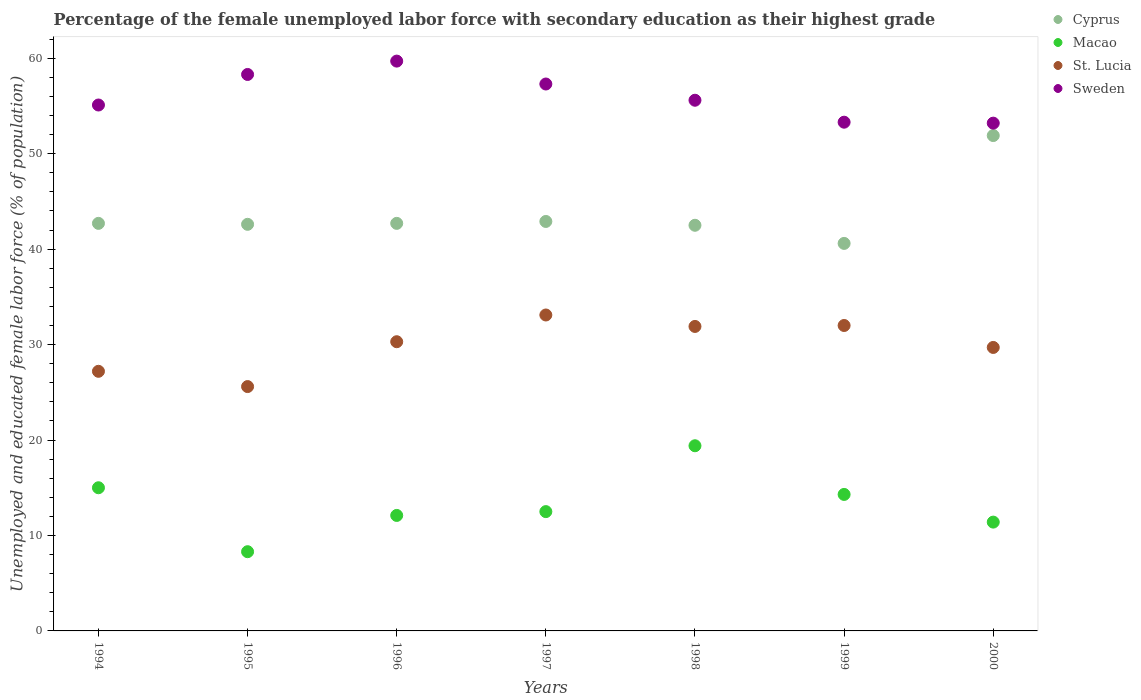What is the percentage of the unemployed female labor force with secondary education in Cyprus in 1999?
Your response must be concise. 40.6. Across all years, what is the maximum percentage of the unemployed female labor force with secondary education in Macao?
Provide a short and direct response. 19.4. Across all years, what is the minimum percentage of the unemployed female labor force with secondary education in Sweden?
Ensure brevity in your answer.  53.2. In which year was the percentage of the unemployed female labor force with secondary education in Cyprus maximum?
Keep it short and to the point. 2000. What is the total percentage of the unemployed female labor force with secondary education in Macao in the graph?
Your response must be concise. 93. What is the difference between the percentage of the unemployed female labor force with secondary education in Cyprus in 1994 and that in 1996?
Offer a very short reply. 0. What is the difference between the percentage of the unemployed female labor force with secondary education in Macao in 1998 and the percentage of the unemployed female labor force with secondary education in St. Lucia in 1995?
Your answer should be compact. -6.2. What is the average percentage of the unemployed female labor force with secondary education in St. Lucia per year?
Keep it short and to the point. 29.97. In the year 1999, what is the difference between the percentage of the unemployed female labor force with secondary education in St. Lucia and percentage of the unemployed female labor force with secondary education in Sweden?
Give a very brief answer. -21.3. What is the ratio of the percentage of the unemployed female labor force with secondary education in Macao in 1995 to that in 2000?
Offer a very short reply. 0.73. What is the difference between the highest and the second highest percentage of the unemployed female labor force with secondary education in Sweden?
Offer a terse response. 1.4. What is the difference between the highest and the lowest percentage of the unemployed female labor force with secondary education in St. Lucia?
Offer a terse response. 7.5. In how many years, is the percentage of the unemployed female labor force with secondary education in Macao greater than the average percentage of the unemployed female labor force with secondary education in Macao taken over all years?
Give a very brief answer. 3. Is the percentage of the unemployed female labor force with secondary education in Cyprus strictly less than the percentage of the unemployed female labor force with secondary education in Macao over the years?
Ensure brevity in your answer.  No. How many dotlines are there?
Make the answer very short. 4. Are the values on the major ticks of Y-axis written in scientific E-notation?
Offer a terse response. No. Does the graph contain any zero values?
Keep it short and to the point. No. Does the graph contain grids?
Offer a terse response. No. What is the title of the graph?
Your answer should be compact. Percentage of the female unemployed labor force with secondary education as their highest grade. Does "Cuba" appear as one of the legend labels in the graph?
Make the answer very short. No. What is the label or title of the X-axis?
Your answer should be very brief. Years. What is the label or title of the Y-axis?
Your answer should be very brief. Unemployed and educated female labor force (% of population). What is the Unemployed and educated female labor force (% of population) of Cyprus in 1994?
Offer a terse response. 42.7. What is the Unemployed and educated female labor force (% of population) of St. Lucia in 1994?
Provide a short and direct response. 27.2. What is the Unemployed and educated female labor force (% of population) of Sweden in 1994?
Give a very brief answer. 55.1. What is the Unemployed and educated female labor force (% of population) of Cyprus in 1995?
Give a very brief answer. 42.6. What is the Unemployed and educated female labor force (% of population) of Macao in 1995?
Give a very brief answer. 8.3. What is the Unemployed and educated female labor force (% of population) in St. Lucia in 1995?
Keep it short and to the point. 25.6. What is the Unemployed and educated female labor force (% of population) of Sweden in 1995?
Provide a succinct answer. 58.3. What is the Unemployed and educated female labor force (% of population) of Cyprus in 1996?
Offer a very short reply. 42.7. What is the Unemployed and educated female labor force (% of population) of Macao in 1996?
Provide a succinct answer. 12.1. What is the Unemployed and educated female labor force (% of population) in St. Lucia in 1996?
Ensure brevity in your answer.  30.3. What is the Unemployed and educated female labor force (% of population) of Sweden in 1996?
Your answer should be very brief. 59.7. What is the Unemployed and educated female labor force (% of population) of Cyprus in 1997?
Your answer should be compact. 42.9. What is the Unemployed and educated female labor force (% of population) in Macao in 1997?
Make the answer very short. 12.5. What is the Unemployed and educated female labor force (% of population) in St. Lucia in 1997?
Provide a succinct answer. 33.1. What is the Unemployed and educated female labor force (% of population) in Sweden in 1997?
Provide a succinct answer. 57.3. What is the Unemployed and educated female labor force (% of population) in Cyprus in 1998?
Offer a terse response. 42.5. What is the Unemployed and educated female labor force (% of population) of Macao in 1998?
Ensure brevity in your answer.  19.4. What is the Unemployed and educated female labor force (% of population) in St. Lucia in 1998?
Give a very brief answer. 31.9. What is the Unemployed and educated female labor force (% of population) in Sweden in 1998?
Give a very brief answer. 55.6. What is the Unemployed and educated female labor force (% of population) of Cyprus in 1999?
Your answer should be very brief. 40.6. What is the Unemployed and educated female labor force (% of population) of Macao in 1999?
Your response must be concise. 14.3. What is the Unemployed and educated female labor force (% of population) in Sweden in 1999?
Offer a very short reply. 53.3. What is the Unemployed and educated female labor force (% of population) of Cyprus in 2000?
Provide a succinct answer. 51.9. What is the Unemployed and educated female labor force (% of population) of Macao in 2000?
Ensure brevity in your answer.  11.4. What is the Unemployed and educated female labor force (% of population) in St. Lucia in 2000?
Offer a terse response. 29.7. What is the Unemployed and educated female labor force (% of population) in Sweden in 2000?
Make the answer very short. 53.2. Across all years, what is the maximum Unemployed and educated female labor force (% of population) in Cyprus?
Your answer should be compact. 51.9. Across all years, what is the maximum Unemployed and educated female labor force (% of population) in Macao?
Ensure brevity in your answer.  19.4. Across all years, what is the maximum Unemployed and educated female labor force (% of population) in St. Lucia?
Your answer should be very brief. 33.1. Across all years, what is the maximum Unemployed and educated female labor force (% of population) of Sweden?
Provide a short and direct response. 59.7. Across all years, what is the minimum Unemployed and educated female labor force (% of population) in Cyprus?
Your response must be concise. 40.6. Across all years, what is the minimum Unemployed and educated female labor force (% of population) of Macao?
Your answer should be very brief. 8.3. Across all years, what is the minimum Unemployed and educated female labor force (% of population) in St. Lucia?
Your response must be concise. 25.6. Across all years, what is the minimum Unemployed and educated female labor force (% of population) of Sweden?
Make the answer very short. 53.2. What is the total Unemployed and educated female labor force (% of population) in Cyprus in the graph?
Make the answer very short. 305.9. What is the total Unemployed and educated female labor force (% of population) in Macao in the graph?
Give a very brief answer. 93. What is the total Unemployed and educated female labor force (% of population) in St. Lucia in the graph?
Offer a very short reply. 209.8. What is the total Unemployed and educated female labor force (% of population) in Sweden in the graph?
Provide a short and direct response. 392.5. What is the difference between the Unemployed and educated female labor force (% of population) of Cyprus in 1994 and that in 1995?
Keep it short and to the point. 0.1. What is the difference between the Unemployed and educated female labor force (% of population) of St. Lucia in 1994 and that in 1995?
Your response must be concise. 1.6. What is the difference between the Unemployed and educated female labor force (% of population) in Macao in 1994 and that in 1996?
Give a very brief answer. 2.9. What is the difference between the Unemployed and educated female labor force (% of population) in St. Lucia in 1994 and that in 1996?
Keep it short and to the point. -3.1. What is the difference between the Unemployed and educated female labor force (% of population) of Sweden in 1994 and that in 1996?
Offer a very short reply. -4.6. What is the difference between the Unemployed and educated female labor force (% of population) in St. Lucia in 1994 and that in 1997?
Provide a succinct answer. -5.9. What is the difference between the Unemployed and educated female labor force (% of population) of Cyprus in 1994 and that in 1999?
Your response must be concise. 2.1. What is the difference between the Unemployed and educated female labor force (% of population) in Sweden in 1994 and that in 1999?
Provide a short and direct response. 1.8. What is the difference between the Unemployed and educated female labor force (% of population) in Cyprus in 1994 and that in 2000?
Offer a very short reply. -9.2. What is the difference between the Unemployed and educated female labor force (% of population) in Cyprus in 1995 and that in 1996?
Offer a very short reply. -0.1. What is the difference between the Unemployed and educated female labor force (% of population) in St. Lucia in 1995 and that in 1996?
Give a very brief answer. -4.7. What is the difference between the Unemployed and educated female labor force (% of population) in Macao in 1995 and that in 1997?
Provide a succinct answer. -4.2. What is the difference between the Unemployed and educated female labor force (% of population) of Cyprus in 1995 and that in 1998?
Ensure brevity in your answer.  0.1. What is the difference between the Unemployed and educated female labor force (% of population) of Macao in 1995 and that in 1998?
Your answer should be compact. -11.1. What is the difference between the Unemployed and educated female labor force (% of population) of St. Lucia in 1995 and that in 1998?
Ensure brevity in your answer.  -6.3. What is the difference between the Unemployed and educated female labor force (% of population) of Cyprus in 1995 and that in 1999?
Offer a terse response. 2. What is the difference between the Unemployed and educated female labor force (% of population) in Macao in 1995 and that in 1999?
Your answer should be very brief. -6. What is the difference between the Unemployed and educated female labor force (% of population) of St. Lucia in 1995 and that in 1999?
Your response must be concise. -6.4. What is the difference between the Unemployed and educated female labor force (% of population) in Cyprus in 1995 and that in 2000?
Your answer should be compact. -9.3. What is the difference between the Unemployed and educated female labor force (% of population) in Sweden in 1995 and that in 2000?
Offer a very short reply. 5.1. What is the difference between the Unemployed and educated female labor force (% of population) in Macao in 1996 and that in 1997?
Provide a short and direct response. -0.4. What is the difference between the Unemployed and educated female labor force (% of population) in St. Lucia in 1996 and that in 1998?
Offer a very short reply. -1.6. What is the difference between the Unemployed and educated female labor force (% of population) in Cyprus in 1996 and that in 1999?
Make the answer very short. 2.1. What is the difference between the Unemployed and educated female labor force (% of population) of Macao in 1996 and that in 1999?
Your response must be concise. -2.2. What is the difference between the Unemployed and educated female labor force (% of population) of St. Lucia in 1996 and that in 1999?
Ensure brevity in your answer.  -1.7. What is the difference between the Unemployed and educated female labor force (% of population) in St. Lucia in 1996 and that in 2000?
Provide a succinct answer. 0.6. What is the difference between the Unemployed and educated female labor force (% of population) in Macao in 1997 and that in 1998?
Keep it short and to the point. -6.9. What is the difference between the Unemployed and educated female labor force (% of population) in Macao in 1997 and that in 1999?
Your answer should be very brief. -1.8. What is the difference between the Unemployed and educated female labor force (% of population) in St. Lucia in 1997 and that in 1999?
Your response must be concise. 1.1. What is the difference between the Unemployed and educated female labor force (% of population) of St. Lucia in 1997 and that in 2000?
Provide a short and direct response. 3.4. What is the difference between the Unemployed and educated female labor force (% of population) in Macao in 1998 and that in 1999?
Offer a terse response. 5.1. What is the difference between the Unemployed and educated female labor force (% of population) in St. Lucia in 1998 and that in 1999?
Offer a terse response. -0.1. What is the difference between the Unemployed and educated female labor force (% of population) of Sweden in 1998 and that in 1999?
Keep it short and to the point. 2.3. What is the difference between the Unemployed and educated female labor force (% of population) of Macao in 1998 and that in 2000?
Your response must be concise. 8. What is the difference between the Unemployed and educated female labor force (% of population) in St. Lucia in 1998 and that in 2000?
Offer a terse response. 2.2. What is the difference between the Unemployed and educated female labor force (% of population) of Macao in 1999 and that in 2000?
Ensure brevity in your answer.  2.9. What is the difference between the Unemployed and educated female labor force (% of population) of St. Lucia in 1999 and that in 2000?
Offer a terse response. 2.3. What is the difference between the Unemployed and educated female labor force (% of population) in Sweden in 1999 and that in 2000?
Keep it short and to the point. 0.1. What is the difference between the Unemployed and educated female labor force (% of population) of Cyprus in 1994 and the Unemployed and educated female labor force (% of population) of Macao in 1995?
Your answer should be compact. 34.4. What is the difference between the Unemployed and educated female labor force (% of population) in Cyprus in 1994 and the Unemployed and educated female labor force (% of population) in St. Lucia in 1995?
Keep it short and to the point. 17.1. What is the difference between the Unemployed and educated female labor force (% of population) of Cyprus in 1994 and the Unemployed and educated female labor force (% of population) of Sweden in 1995?
Your answer should be compact. -15.6. What is the difference between the Unemployed and educated female labor force (% of population) of Macao in 1994 and the Unemployed and educated female labor force (% of population) of Sweden in 1995?
Give a very brief answer. -43.3. What is the difference between the Unemployed and educated female labor force (% of population) of St. Lucia in 1994 and the Unemployed and educated female labor force (% of population) of Sweden in 1995?
Offer a very short reply. -31.1. What is the difference between the Unemployed and educated female labor force (% of population) in Cyprus in 1994 and the Unemployed and educated female labor force (% of population) in Macao in 1996?
Ensure brevity in your answer.  30.6. What is the difference between the Unemployed and educated female labor force (% of population) of Cyprus in 1994 and the Unemployed and educated female labor force (% of population) of St. Lucia in 1996?
Ensure brevity in your answer.  12.4. What is the difference between the Unemployed and educated female labor force (% of population) in Macao in 1994 and the Unemployed and educated female labor force (% of population) in St. Lucia in 1996?
Your answer should be very brief. -15.3. What is the difference between the Unemployed and educated female labor force (% of population) of Macao in 1994 and the Unemployed and educated female labor force (% of population) of Sweden in 1996?
Your answer should be compact. -44.7. What is the difference between the Unemployed and educated female labor force (% of population) in St. Lucia in 1994 and the Unemployed and educated female labor force (% of population) in Sweden in 1996?
Give a very brief answer. -32.5. What is the difference between the Unemployed and educated female labor force (% of population) of Cyprus in 1994 and the Unemployed and educated female labor force (% of population) of Macao in 1997?
Provide a short and direct response. 30.2. What is the difference between the Unemployed and educated female labor force (% of population) of Cyprus in 1994 and the Unemployed and educated female labor force (% of population) of Sweden in 1997?
Offer a very short reply. -14.6. What is the difference between the Unemployed and educated female labor force (% of population) of Macao in 1994 and the Unemployed and educated female labor force (% of population) of St. Lucia in 1997?
Provide a succinct answer. -18.1. What is the difference between the Unemployed and educated female labor force (% of population) of Macao in 1994 and the Unemployed and educated female labor force (% of population) of Sweden in 1997?
Provide a succinct answer. -42.3. What is the difference between the Unemployed and educated female labor force (% of population) in St. Lucia in 1994 and the Unemployed and educated female labor force (% of population) in Sweden in 1997?
Give a very brief answer. -30.1. What is the difference between the Unemployed and educated female labor force (% of population) in Cyprus in 1994 and the Unemployed and educated female labor force (% of population) in Macao in 1998?
Make the answer very short. 23.3. What is the difference between the Unemployed and educated female labor force (% of population) in Cyprus in 1994 and the Unemployed and educated female labor force (% of population) in St. Lucia in 1998?
Offer a very short reply. 10.8. What is the difference between the Unemployed and educated female labor force (% of population) in Macao in 1994 and the Unemployed and educated female labor force (% of population) in St. Lucia in 1998?
Provide a short and direct response. -16.9. What is the difference between the Unemployed and educated female labor force (% of population) of Macao in 1994 and the Unemployed and educated female labor force (% of population) of Sweden in 1998?
Your answer should be compact. -40.6. What is the difference between the Unemployed and educated female labor force (% of population) of St. Lucia in 1994 and the Unemployed and educated female labor force (% of population) of Sweden in 1998?
Keep it short and to the point. -28.4. What is the difference between the Unemployed and educated female labor force (% of population) in Cyprus in 1994 and the Unemployed and educated female labor force (% of population) in Macao in 1999?
Make the answer very short. 28.4. What is the difference between the Unemployed and educated female labor force (% of population) of Macao in 1994 and the Unemployed and educated female labor force (% of population) of Sweden in 1999?
Keep it short and to the point. -38.3. What is the difference between the Unemployed and educated female labor force (% of population) in St. Lucia in 1994 and the Unemployed and educated female labor force (% of population) in Sweden in 1999?
Offer a very short reply. -26.1. What is the difference between the Unemployed and educated female labor force (% of population) of Cyprus in 1994 and the Unemployed and educated female labor force (% of population) of Macao in 2000?
Give a very brief answer. 31.3. What is the difference between the Unemployed and educated female labor force (% of population) of Macao in 1994 and the Unemployed and educated female labor force (% of population) of St. Lucia in 2000?
Give a very brief answer. -14.7. What is the difference between the Unemployed and educated female labor force (% of population) of Macao in 1994 and the Unemployed and educated female labor force (% of population) of Sweden in 2000?
Provide a short and direct response. -38.2. What is the difference between the Unemployed and educated female labor force (% of population) in St. Lucia in 1994 and the Unemployed and educated female labor force (% of population) in Sweden in 2000?
Your response must be concise. -26. What is the difference between the Unemployed and educated female labor force (% of population) of Cyprus in 1995 and the Unemployed and educated female labor force (% of population) of Macao in 1996?
Offer a very short reply. 30.5. What is the difference between the Unemployed and educated female labor force (% of population) in Cyprus in 1995 and the Unemployed and educated female labor force (% of population) in St. Lucia in 1996?
Offer a very short reply. 12.3. What is the difference between the Unemployed and educated female labor force (% of population) in Cyprus in 1995 and the Unemployed and educated female labor force (% of population) in Sweden in 1996?
Give a very brief answer. -17.1. What is the difference between the Unemployed and educated female labor force (% of population) in Macao in 1995 and the Unemployed and educated female labor force (% of population) in St. Lucia in 1996?
Provide a succinct answer. -22. What is the difference between the Unemployed and educated female labor force (% of population) of Macao in 1995 and the Unemployed and educated female labor force (% of population) of Sweden in 1996?
Your answer should be very brief. -51.4. What is the difference between the Unemployed and educated female labor force (% of population) in St. Lucia in 1995 and the Unemployed and educated female labor force (% of population) in Sweden in 1996?
Provide a succinct answer. -34.1. What is the difference between the Unemployed and educated female labor force (% of population) of Cyprus in 1995 and the Unemployed and educated female labor force (% of population) of Macao in 1997?
Keep it short and to the point. 30.1. What is the difference between the Unemployed and educated female labor force (% of population) in Cyprus in 1995 and the Unemployed and educated female labor force (% of population) in St. Lucia in 1997?
Your answer should be compact. 9.5. What is the difference between the Unemployed and educated female labor force (% of population) of Cyprus in 1995 and the Unemployed and educated female labor force (% of population) of Sweden in 1997?
Offer a very short reply. -14.7. What is the difference between the Unemployed and educated female labor force (% of population) in Macao in 1995 and the Unemployed and educated female labor force (% of population) in St. Lucia in 1997?
Offer a terse response. -24.8. What is the difference between the Unemployed and educated female labor force (% of population) of Macao in 1995 and the Unemployed and educated female labor force (% of population) of Sweden in 1997?
Make the answer very short. -49. What is the difference between the Unemployed and educated female labor force (% of population) in St. Lucia in 1995 and the Unemployed and educated female labor force (% of population) in Sweden in 1997?
Your answer should be compact. -31.7. What is the difference between the Unemployed and educated female labor force (% of population) in Cyprus in 1995 and the Unemployed and educated female labor force (% of population) in Macao in 1998?
Provide a succinct answer. 23.2. What is the difference between the Unemployed and educated female labor force (% of population) of Cyprus in 1995 and the Unemployed and educated female labor force (% of population) of St. Lucia in 1998?
Give a very brief answer. 10.7. What is the difference between the Unemployed and educated female labor force (% of population) of Macao in 1995 and the Unemployed and educated female labor force (% of population) of St. Lucia in 1998?
Make the answer very short. -23.6. What is the difference between the Unemployed and educated female labor force (% of population) of Macao in 1995 and the Unemployed and educated female labor force (% of population) of Sweden in 1998?
Make the answer very short. -47.3. What is the difference between the Unemployed and educated female labor force (% of population) of St. Lucia in 1995 and the Unemployed and educated female labor force (% of population) of Sweden in 1998?
Offer a very short reply. -30. What is the difference between the Unemployed and educated female labor force (% of population) in Cyprus in 1995 and the Unemployed and educated female labor force (% of population) in Macao in 1999?
Offer a terse response. 28.3. What is the difference between the Unemployed and educated female labor force (% of population) in Cyprus in 1995 and the Unemployed and educated female labor force (% of population) in St. Lucia in 1999?
Your answer should be very brief. 10.6. What is the difference between the Unemployed and educated female labor force (% of population) of Cyprus in 1995 and the Unemployed and educated female labor force (% of population) of Sweden in 1999?
Your response must be concise. -10.7. What is the difference between the Unemployed and educated female labor force (% of population) in Macao in 1995 and the Unemployed and educated female labor force (% of population) in St. Lucia in 1999?
Your answer should be compact. -23.7. What is the difference between the Unemployed and educated female labor force (% of population) in Macao in 1995 and the Unemployed and educated female labor force (% of population) in Sweden in 1999?
Offer a terse response. -45. What is the difference between the Unemployed and educated female labor force (% of population) of St. Lucia in 1995 and the Unemployed and educated female labor force (% of population) of Sweden in 1999?
Provide a short and direct response. -27.7. What is the difference between the Unemployed and educated female labor force (% of population) of Cyprus in 1995 and the Unemployed and educated female labor force (% of population) of Macao in 2000?
Make the answer very short. 31.2. What is the difference between the Unemployed and educated female labor force (% of population) of Cyprus in 1995 and the Unemployed and educated female labor force (% of population) of St. Lucia in 2000?
Your answer should be very brief. 12.9. What is the difference between the Unemployed and educated female labor force (% of population) of Macao in 1995 and the Unemployed and educated female labor force (% of population) of St. Lucia in 2000?
Give a very brief answer. -21.4. What is the difference between the Unemployed and educated female labor force (% of population) of Macao in 1995 and the Unemployed and educated female labor force (% of population) of Sweden in 2000?
Give a very brief answer. -44.9. What is the difference between the Unemployed and educated female labor force (% of population) in St. Lucia in 1995 and the Unemployed and educated female labor force (% of population) in Sweden in 2000?
Provide a short and direct response. -27.6. What is the difference between the Unemployed and educated female labor force (% of population) of Cyprus in 1996 and the Unemployed and educated female labor force (% of population) of Macao in 1997?
Ensure brevity in your answer.  30.2. What is the difference between the Unemployed and educated female labor force (% of population) of Cyprus in 1996 and the Unemployed and educated female labor force (% of population) of St. Lucia in 1997?
Provide a succinct answer. 9.6. What is the difference between the Unemployed and educated female labor force (% of population) in Cyprus in 1996 and the Unemployed and educated female labor force (% of population) in Sweden in 1997?
Provide a short and direct response. -14.6. What is the difference between the Unemployed and educated female labor force (% of population) in Macao in 1996 and the Unemployed and educated female labor force (% of population) in Sweden in 1997?
Make the answer very short. -45.2. What is the difference between the Unemployed and educated female labor force (% of population) of St. Lucia in 1996 and the Unemployed and educated female labor force (% of population) of Sweden in 1997?
Offer a very short reply. -27. What is the difference between the Unemployed and educated female labor force (% of population) in Cyprus in 1996 and the Unemployed and educated female labor force (% of population) in Macao in 1998?
Offer a very short reply. 23.3. What is the difference between the Unemployed and educated female labor force (% of population) in Cyprus in 1996 and the Unemployed and educated female labor force (% of population) in Sweden in 1998?
Offer a terse response. -12.9. What is the difference between the Unemployed and educated female labor force (% of population) of Macao in 1996 and the Unemployed and educated female labor force (% of population) of St. Lucia in 1998?
Offer a terse response. -19.8. What is the difference between the Unemployed and educated female labor force (% of population) of Macao in 1996 and the Unemployed and educated female labor force (% of population) of Sweden in 1998?
Offer a terse response. -43.5. What is the difference between the Unemployed and educated female labor force (% of population) in St. Lucia in 1996 and the Unemployed and educated female labor force (% of population) in Sweden in 1998?
Provide a short and direct response. -25.3. What is the difference between the Unemployed and educated female labor force (% of population) of Cyprus in 1996 and the Unemployed and educated female labor force (% of population) of Macao in 1999?
Offer a terse response. 28.4. What is the difference between the Unemployed and educated female labor force (% of population) of Cyprus in 1996 and the Unemployed and educated female labor force (% of population) of St. Lucia in 1999?
Make the answer very short. 10.7. What is the difference between the Unemployed and educated female labor force (% of population) of Macao in 1996 and the Unemployed and educated female labor force (% of population) of St. Lucia in 1999?
Offer a very short reply. -19.9. What is the difference between the Unemployed and educated female labor force (% of population) of Macao in 1996 and the Unemployed and educated female labor force (% of population) of Sweden in 1999?
Your answer should be very brief. -41.2. What is the difference between the Unemployed and educated female labor force (% of population) in St. Lucia in 1996 and the Unemployed and educated female labor force (% of population) in Sweden in 1999?
Provide a short and direct response. -23. What is the difference between the Unemployed and educated female labor force (% of population) in Cyprus in 1996 and the Unemployed and educated female labor force (% of population) in Macao in 2000?
Your answer should be compact. 31.3. What is the difference between the Unemployed and educated female labor force (% of population) in Macao in 1996 and the Unemployed and educated female labor force (% of population) in St. Lucia in 2000?
Give a very brief answer. -17.6. What is the difference between the Unemployed and educated female labor force (% of population) of Macao in 1996 and the Unemployed and educated female labor force (% of population) of Sweden in 2000?
Make the answer very short. -41.1. What is the difference between the Unemployed and educated female labor force (% of population) of St. Lucia in 1996 and the Unemployed and educated female labor force (% of population) of Sweden in 2000?
Ensure brevity in your answer.  -22.9. What is the difference between the Unemployed and educated female labor force (% of population) of Macao in 1997 and the Unemployed and educated female labor force (% of population) of St. Lucia in 1998?
Offer a very short reply. -19.4. What is the difference between the Unemployed and educated female labor force (% of population) in Macao in 1997 and the Unemployed and educated female labor force (% of population) in Sweden in 1998?
Your answer should be compact. -43.1. What is the difference between the Unemployed and educated female labor force (% of population) of St. Lucia in 1997 and the Unemployed and educated female labor force (% of population) of Sweden in 1998?
Offer a very short reply. -22.5. What is the difference between the Unemployed and educated female labor force (% of population) in Cyprus in 1997 and the Unemployed and educated female labor force (% of population) in Macao in 1999?
Make the answer very short. 28.6. What is the difference between the Unemployed and educated female labor force (% of population) in Cyprus in 1997 and the Unemployed and educated female labor force (% of population) in Sweden in 1999?
Offer a very short reply. -10.4. What is the difference between the Unemployed and educated female labor force (% of population) of Macao in 1997 and the Unemployed and educated female labor force (% of population) of St. Lucia in 1999?
Offer a terse response. -19.5. What is the difference between the Unemployed and educated female labor force (% of population) of Macao in 1997 and the Unemployed and educated female labor force (% of population) of Sweden in 1999?
Offer a terse response. -40.8. What is the difference between the Unemployed and educated female labor force (% of population) of St. Lucia in 1997 and the Unemployed and educated female labor force (% of population) of Sweden in 1999?
Keep it short and to the point. -20.2. What is the difference between the Unemployed and educated female labor force (% of population) in Cyprus in 1997 and the Unemployed and educated female labor force (% of population) in Macao in 2000?
Your answer should be compact. 31.5. What is the difference between the Unemployed and educated female labor force (% of population) of Macao in 1997 and the Unemployed and educated female labor force (% of population) of St. Lucia in 2000?
Make the answer very short. -17.2. What is the difference between the Unemployed and educated female labor force (% of population) in Macao in 1997 and the Unemployed and educated female labor force (% of population) in Sweden in 2000?
Provide a succinct answer. -40.7. What is the difference between the Unemployed and educated female labor force (% of population) of St. Lucia in 1997 and the Unemployed and educated female labor force (% of population) of Sweden in 2000?
Offer a terse response. -20.1. What is the difference between the Unemployed and educated female labor force (% of population) of Cyprus in 1998 and the Unemployed and educated female labor force (% of population) of Macao in 1999?
Keep it short and to the point. 28.2. What is the difference between the Unemployed and educated female labor force (% of population) in Cyprus in 1998 and the Unemployed and educated female labor force (% of population) in Sweden in 1999?
Offer a terse response. -10.8. What is the difference between the Unemployed and educated female labor force (% of population) in Macao in 1998 and the Unemployed and educated female labor force (% of population) in St. Lucia in 1999?
Keep it short and to the point. -12.6. What is the difference between the Unemployed and educated female labor force (% of population) in Macao in 1998 and the Unemployed and educated female labor force (% of population) in Sweden in 1999?
Offer a very short reply. -33.9. What is the difference between the Unemployed and educated female labor force (% of population) of St. Lucia in 1998 and the Unemployed and educated female labor force (% of population) of Sweden in 1999?
Your response must be concise. -21.4. What is the difference between the Unemployed and educated female labor force (% of population) in Cyprus in 1998 and the Unemployed and educated female labor force (% of population) in Macao in 2000?
Offer a terse response. 31.1. What is the difference between the Unemployed and educated female labor force (% of population) of Macao in 1998 and the Unemployed and educated female labor force (% of population) of Sweden in 2000?
Keep it short and to the point. -33.8. What is the difference between the Unemployed and educated female labor force (% of population) in St. Lucia in 1998 and the Unemployed and educated female labor force (% of population) in Sweden in 2000?
Your response must be concise. -21.3. What is the difference between the Unemployed and educated female labor force (% of population) of Cyprus in 1999 and the Unemployed and educated female labor force (% of population) of Macao in 2000?
Keep it short and to the point. 29.2. What is the difference between the Unemployed and educated female labor force (% of population) of Cyprus in 1999 and the Unemployed and educated female labor force (% of population) of Sweden in 2000?
Make the answer very short. -12.6. What is the difference between the Unemployed and educated female labor force (% of population) of Macao in 1999 and the Unemployed and educated female labor force (% of population) of St. Lucia in 2000?
Make the answer very short. -15.4. What is the difference between the Unemployed and educated female labor force (% of population) of Macao in 1999 and the Unemployed and educated female labor force (% of population) of Sweden in 2000?
Your answer should be compact. -38.9. What is the difference between the Unemployed and educated female labor force (% of population) in St. Lucia in 1999 and the Unemployed and educated female labor force (% of population) in Sweden in 2000?
Offer a very short reply. -21.2. What is the average Unemployed and educated female labor force (% of population) of Cyprus per year?
Offer a very short reply. 43.7. What is the average Unemployed and educated female labor force (% of population) in Macao per year?
Your answer should be very brief. 13.29. What is the average Unemployed and educated female labor force (% of population) in St. Lucia per year?
Your response must be concise. 29.97. What is the average Unemployed and educated female labor force (% of population) of Sweden per year?
Your answer should be very brief. 56.07. In the year 1994, what is the difference between the Unemployed and educated female labor force (% of population) of Cyprus and Unemployed and educated female labor force (% of population) of Macao?
Provide a succinct answer. 27.7. In the year 1994, what is the difference between the Unemployed and educated female labor force (% of population) of Cyprus and Unemployed and educated female labor force (% of population) of Sweden?
Ensure brevity in your answer.  -12.4. In the year 1994, what is the difference between the Unemployed and educated female labor force (% of population) in Macao and Unemployed and educated female labor force (% of population) in St. Lucia?
Your response must be concise. -12.2. In the year 1994, what is the difference between the Unemployed and educated female labor force (% of population) in Macao and Unemployed and educated female labor force (% of population) in Sweden?
Provide a succinct answer. -40.1. In the year 1994, what is the difference between the Unemployed and educated female labor force (% of population) of St. Lucia and Unemployed and educated female labor force (% of population) of Sweden?
Ensure brevity in your answer.  -27.9. In the year 1995, what is the difference between the Unemployed and educated female labor force (% of population) in Cyprus and Unemployed and educated female labor force (% of population) in Macao?
Ensure brevity in your answer.  34.3. In the year 1995, what is the difference between the Unemployed and educated female labor force (% of population) of Cyprus and Unemployed and educated female labor force (% of population) of St. Lucia?
Keep it short and to the point. 17. In the year 1995, what is the difference between the Unemployed and educated female labor force (% of population) in Cyprus and Unemployed and educated female labor force (% of population) in Sweden?
Keep it short and to the point. -15.7. In the year 1995, what is the difference between the Unemployed and educated female labor force (% of population) of Macao and Unemployed and educated female labor force (% of population) of St. Lucia?
Ensure brevity in your answer.  -17.3. In the year 1995, what is the difference between the Unemployed and educated female labor force (% of population) of Macao and Unemployed and educated female labor force (% of population) of Sweden?
Ensure brevity in your answer.  -50. In the year 1995, what is the difference between the Unemployed and educated female labor force (% of population) in St. Lucia and Unemployed and educated female labor force (% of population) in Sweden?
Keep it short and to the point. -32.7. In the year 1996, what is the difference between the Unemployed and educated female labor force (% of population) in Cyprus and Unemployed and educated female labor force (% of population) in Macao?
Offer a very short reply. 30.6. In the year 1996, what is the difference between the Unemployed and educated female labor force (% of population) in Macao and Unemployed and educated female labor force (% of population) in St. Lucia?
Provide a short and direct response. -18.2. In the year 1996, what is the difference between the Unemployed and educated female labor force (% of population) in Macao and Unemployed and educated female labor force (% of population) in Sweden?
Ensure brevity in your answer.  -47.6. In the year 1996, what is the difference between the Unemployed and educated female labor force (% of population) of St. Lucia and Unemployed and educated female labor force (% of population) of Sweden?
Provide a succinct answer. -29.4. In the year 1997, what is the difference between the Unemployed and educated female labor force (% of population) of Cyprus and Unemployed and educated female labor force (% of population) of Macao?
Your answer should be compact. 30.4. In the year 1997, what is the difference between the Unemployed and educated female labor force (% of population) of Cyprus and Unemployed and educated female labor force (% of population) of St. Lucia?
Your answer should be very brief. 9.8. In the year 1997, what is the difference between the Unemployed and educated female labor force (% of population) in Cyprus and Unemployed and educated female labor force (% of population) in Sweden?
Make the answer very short. -14.4. In the year 1997, what is the difference between the Unemployed and educated female labor force (% of population) in Macao and Unemployed and educated female labor force (% of population) in St. Lucia?
Your answer should be compact. -20.6. In the year 1997, what is the difference between the Unemployed and educated female labor force (% of population) in Macao and Unemployed and educated female labor force (% of population) in Sweden?
Make the answer very short. -44.8. In the year 1997, what is the difference between the Unemployed and educated female labor force (% of population) of St. Lucia and Unemployed and educated female labor force (% of population) of Sweden?
Offer a very short reply. -24.2. In the year 1998, what is the difference between the Unemployed and educated female labor force (% of population) of Cyprus and Unemployed and educated female labor force (% of population) of Macao?
Offer a very short reply. 23.1. In the year 1998, what is the difference between the Unemployed and educated female labor force (% of population) in Cyprus and Unemployed and educated female labor force (% of population) in Sweden?
Your answer should be compact. -13.1. In the year 1998, what is the difference between the Unemployed and educated female labor force (% of population) of Macao and Unemployed and educated female labor force (% of population) of Sweden?
Your answer should be very brief. -36.2. In the year 1998, what is the difference between the Unemployed and educated female labor force (% of population) in St. Lucia and Unemployed and educated female labor force (% of population) in Sweden?
Give a very brief answer. -23.7. In the year 1999, what is the difference between the Unemployed and educated female labor force (% of population) of Cyprus and Unemployed and educated female labor force (% of population) of Macao?
Offer a terse response. 26.3. In the year 1999, what is the difference between the Unemployed and educated female labor force (% of population) of Cyprus and Unemployed and educated female labor force (% of population) of St. Lucia?
Offer a terse response. 8.6. In the year 1999, what is the difference between the Unemployed and educated female labor force (% of population) in Cyprus and Unemployed and educated female labor force (% of population) in Sweden?
Your response must be concise. -12.7. In the year 1999, what is the difference between the Unemployed and educated female labor force (% of population) of Macao and Unemployed and educated female labor force (% of population) of St. Lucia?
Give a very brief answer. -17.7. In the year 1999, what is the difference between the Unemployed and educated female labor force (% of population) of Macao and Unemployed and educated female labor force (% of population) of Sweden?
Your response must be concise. -39. In the year 1999, what is the difference between the Unemployed and educated female labor force (% of population) of St. Lucia and Unemployed and educated female labor force (% of population) of Sweden?
Provide a succinct answer. -21.3. In the year 2000, what is the difference between the Unemployed and educated female labor force (% of population) in Cyprus and Unemployed and educated female labor force (% of population) in Macao?
Keep it short and to the point. 40.5. In the year 2000, what is the difference between the Unemployed and educated female labor force (% of population) in Cyprus and Unemployed and educated female labor force (% of population) in St. Lucia?
Give a very brief answer. 22.2. In the year 2000, what is the difference between the Unemployed and educated female labor force (% of population) in Macao and Unemployed and educated female labor force (% of population) in St. Lucia?
Your answer should be compact. -18.3. In the year 2000, what is the difference between the Unemployed and educated female labor force (% of population) of Macao and Unemployed and educated female labor force (% of population) of Sweden?
Your response must be concise. -41.8. In the year 2000, what is the difference between the Unemployed and educated female labor force (% of population) of St. Lucia and Unemployed and educated female labor force (% of population) of Sweden?
Ensure brevity in your answer.  -23.5. What is the ratio of the Unemployed and educated female labor force (% of population) of Macao in 1994 to that in 1995?
Offer a very short reply. 1.81. What is the ratio of the Unemployed and educated female labor force (% of population) in St. Lucia in 1994 to that in 1995?
Provide a succinct answer. 1.06. What is the ratio of the Unemployed and educated female labor force (% of population) of Sweden in 1994 to that in 1995?
Offer a very short reply. 0.95. What is the ratio of the Unemployed and educated female labor force (% of population) of Macao in 1994 to that in 1996?
Provide a succinct answer. 1.24. What is the ratio of the Unemployed and educated female labor force (% of population) of St. Lucia in 1994 to that in 1996?
Your answer should be compact. 0.9. What is the ratio of the Unemployed and educated female labor force (% of population) of Sweden in 1994 to that in 1996?
Your answer should be compact. 0.92. What is the ratio of the Unemployed and educated female labor force (% of population) of Cyprus in 1994 to that in 1997?
Provide a succinct answer. 1. What is the ratio of the Unemployed and educated female labor force (% of population) in St. Lucia in 1994 to that in 1997?
Offer a very short reply. 0.82. What is the ratio of the Unemployed and educated female labor force (% of population) of Sweden in 1994 to that in 1997?
Your response must be concise. 0.96. What is the ratio of the Unemployed and educated female labor force (% of population) of Macao in 1994 to that in 1998?
Make the answer very short. 0.77. What is the ratio of the Unemployed and educated female labor force (% of population) in St. Lucia in 1994 to that in 1998?
Offer a terse response. 0.85. What is the ratio of the Unemployed and educated female labor force (% of population) of Cyprus in 1994 to that in 1999?
Your answer should be very brief. 1.05. What is the ratio of the Unemployed and educated female labor force (% of population) in Macao in 1994 to that in 1999?
Offer a terse response. 1.05. What is the ratio of the Unemployed and educated female labor force (% of population) in Sweden in 1994 to that in 1999?
Your response must be concise. 1.03. What is the ratio of the Unemployed and educated female labor force (% of population) of Cyprus in 1994 to that in 2000?
Your answer should be very brief. 0.82. What is the ratio of the Unemployed and educated female labor force (% of population) in Macao in 1994 to that in 2000?
Provide a succinct answer. 1.32. What is the ratio of the Unemployed and educated female labor force (% of population) in St. Lucia in 1994 to that in 2000?
Offer a very short reply. 0.92. What is the ratio of the Unemployed and educated female labor force (% of population) in Sweden in 1994 to that in 2000?
Your answer should be compact. 1.04. What is the ratio of the Unemployed and educated female labor force (% of population) of Macao in 1995 to that in 1996?
Your answer should be very brief. 0.69. What is the ratio of the Unemployed and educated female labor force (% of population) of St. Lucia in 1995 to that in 1996?
Your answer should be compact. 0.84. What is the ratio of the Unemployed and educated female labor force (% of population) in Sweden in 1995 to that in 1996?
Offer a terse response. 0.98. What is the ratio of the Unemployed and educated female labor force (% of population) of Cyprus in 1995 to that in 1997?
Keep it short and to the point. 0.99. What is the ratio of the Unemployed and educated female labor force (% of population) of Macao in 1995 to that in 1997?
Give a very brief answer. 0.66. What is the ratio of the Unemployed and educated female labor force (% of population) of St. Lucia in 1995 to that in 1997?
Your answer should be compact. 0.77. What is the ratio of the Unemployed and educated female labor force (% of population) of Sweden in 1995 to that in 1997?
Offer a very short reply. 1.02. What is the ratio of the Unemployed and educated female labor force (% of population) in Macao in 1995 to that in 1998?
Ensure brevity in your answer.  0.43. What is the ratio of the Unemployed and educated female labor force (% of population) of St. Lucia in 1995 to that in 1998?
Provide a short and direct response. 0.8. What is the ratio of the Unemployed and educated female labor force (% of population) in Sweden in 1995 to that in 1998?
Your response must be concise. 1.05. What is the ratio of the Unemployed and educated female labor force (% of population) of Cyprus in 1995 to that in 1999?
Offer a very short reply. 1.05. What is the ratio of the Unemployed and educated female labor force (% of population) of Macao in 1995 to that in 1999?
Your response must be concise. 0.58. What is the ratio of the Unemployed and educated female labor force (% of population) in St. Lucia in 1995 to that in 1999?
Offer a terse response. 0.8. What is the ratio of the Unemployed and educated female labor force (% of population) in Sweden in 1995 to that in 1999?
Make the answer very short. 1.09. What is the ratio of the Unemployed and educated female labor force (% of population) in Cyprus in 1995 to that in 2000?
Keep it short and to the point. 0.82. What is the ratio of the Unemployed and educated female labor force (% of population) of Macao in 1995 to that in 2000?
Your answer should be compact. 0.73. What is the ratio of the Unemployed and educated female labor force (% of population) of St. Lucia in 1995 to that in 2000?
Make the answer very short. 0.86. What is the ratio of the Unemployed and educated female labor force (% of population) of Sweden in 1995 to that in 2000?
Your answer should be very brief. 1.1. What is the ratio of the Unemployed and educated female labor force (% of population) in Cyprus in 1996 to that in 1997?
Give a very brief answer. 1. What is the ratio of the Unemployed and educated female labor force (% of population) of St. Lucia in 1996 to that in 1997?
Give a very brief answer. 0.92. What is the ratio of the Unemployed and educated female labor force (% of population) in Sweden in 1996 to that in 1997?
Your response must be concise. 1.04. What is the ratio of the Unemployed and educated female labor force (% of population) of Cyprus in 1996 to that in 1998?
Make the answer very short. 1. What is the ratio of the Unemployed and educated female labor force (% of population) of Macao in 1996 to that in 1998?
Your answer should be compact. 0.62. What is the ratio of the Unemployed and educated female labor force (% of population) of St. Lucia in 1996 to that in 1998?
Provide a short and direct response. 0.95. What is the ratio of the Unemployed and educated female labor force (% of population) of Sweden in 1996 to that in 1998?
Provide a short and direct response. 1.07. What is the ratio of the Unemployed and educated female labor force (% of population) in Cyprus in 1996 to that in 1999?
Your response must be concise. 1.05. What is the ratio of the Unemployed and educated female labor force (% of population) in Macao in 1996 to that in 1999?
Your response must be concise. 0.85. What is the ratio of the Unemployed and educated female labor force (% of population) in St. Lucia in 1996 to that in 1999?
Offer a very short reply. 0.95. What is the ratio of the Unemployed and educated female labor force (% of population) in Sweden in 1996 to that in 1999?
Offer a terse response. 1.12. What is the ratio of the Unemployed and educated female labor force (% of population) of Cyprus in 1996 to that in 2000?
Your answer should be compact. 0.82. What is the ratio of the Unemployed and educated female labor force (% of population) of Macao in 1996 to that in 2000?
Your answer should be very brief. 1.06. What is the ratio of the Unemployed and educated female labor force (% of population) in St. Lucia in 1996 to that in 2000?
Your answer should be compact. 1.02. What is the ratio of the Unemployed and educated female labor force (% of population) of Sweden in 1996 to that in 2000?
Provide a short and direct response. 1.12. What is the ratio of the Unemployed and educated female labor force (% of population) in Cyprus in 1997 to that in 1998?
Provide a short and direct response. 1.01. What is the ratio of the Unemployed and educated female labor force (% of population) of Macao in 1997 to that in 1998?
Provide a succinct answer. 0.64. What is the ratio of the Unemployed and educated female labor force (% of population) of St. Lucia in 1997 to that in 1998?
Make the answer very short. 1.04. What is the ratio of the Unemployed and educated female labor force (% of population) in Sweden in 1997 to that in 1998?
Your response must be concise. 1.03. What is the ratio of the Unemployed and educated female labor force (% of population) of Cyprus in 1997 to that in 1999?
Keep it short and to the point. 1.06. What is the ratio of the Unemployed and educated female labor force (% of population) in Macao in 1997 to that in 1999?
Provide a succinct answer. 0.87. What is the ratio of the Unemployed and educated female labor force (% of population) in St. Lucia in 1997 to that in 1999?
Offer a very short reply. 1.03. What is the ratio of the Unemployed and educated female labor force (% of population) of Sweden in 1997 to that in 1999?
Provide a short and direct response. 1.07. What is the ratio of the Unemployed and educated female labor force (% of population) of Cyprus in 1997 to that in 2000?
Make the answer very short. 0.83. What is the ratio of the Unemployed and educated female labor force (% of population) in Macao in 1997 to that in 2000?
Offer a terse response. 1.1. What is the ratio of the Unemployed and educated female labor force (% of population) of St. Lucia in 1997 to that in 2000?
Give a very brief answer. 1.11. What is the ratio of the Unemployed and educated female labor force (% of population) of Sweden in 1997 to that in 2000?
Your response must be concise. 1.08. What is the ratio of the Unemployed and educated female labor force (% of population) in Cyprus in 1998 to that in 1999?
Provide a succinct answer. 1.05. What is the ratio of the Unemployed and educated female labor force (% of population) in Macao in 1998 to that in 1999?
Make the answer very short. 1.36. What is the ratio of the Unemployed and educated female labor force (% of population) of St. Lucia in 1998 to that in 1999?
Offer a very short reply. 1. What is the ratio of the Unemployed and educated female labor force (% of population) in Sweden in 1998 to that in 1999?
Your answer should be very brief. 1.04. What is the ratio of the Unemployed and educated female labor force (% of population) of Cyprus in 1998 to that in 2000?
Keep it short and to the point. 0.82. What is the ratio of the Unemployed and educated female labor force (% of population) of Macao in 1998 to that in 2000?
Your response must be concise. 1.7. What is the ratio of the Unemployed and educated female labor force (% of population) of St. Lucia in 1998 to that in 2000?
Provide a succinct answer. 1.07. What is the ratio of the Unemployed and educated female labor force (% of population) of Sweden in 1998 to that in 2000?
Keep it short and to the point. 1.05. What is the ratio of the Unemployed and educated female labor force (% of population) of Cyprus in 1999 to that in 2000?
Ensure brevity in your answer.  0.78. What is the ratio of the Unemployed and educated female labor force (% of population) in Macao in 1999 to that in 2000?
Offer a terse response. 1.25. What is the ratio of the Unemployed and educated female labor force (% of population) in St. Lucia in 1999 to that in 2000?
Make the answer very short. 1.08. What is the ratio of the Unemployed and educated female labor force (% of population) of Sweden in 1999 to that in 2000?
Your answer should be very brief. 1. What is the difference between the highest and the second highest Unemployed and educated female labor force (% of population) of Macao?
Make the answer very short. 4.4. What is the difference between the highest and the second highest Unemployed and educated female labor force (% of population) of St. Lucia?
Your response must be concise. 1.1. What is the difference between the highest and the lowest Unemployed and educated female labor force (% of population) of Cyprus?
Give a very brief answer. 11.3. What is the difference between the highest and the lowest Unemployed and educated female labor force (% of population) of Sweden?
Ensure brevity in your answer.  6.5. 